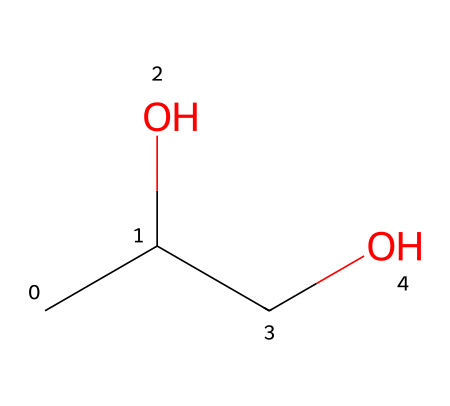What is the name of this chemical? The SMILES representation indicates a linear structure with a specific arrangement of carbon and oxygen atoms. This corresponds to the well-known compound used as a preservative, which is propylene glycol.
Answer: propylene glycol How many carbon atoms are in this molecule? Analyzing the SMILES structure, we identify two carbon atoms represented by the "C" characters. Thus, there are two carbon atoms in total.
Answer: two What functional groups are present in propylene glycol? Reviewing the structure reveals hydroxyl groups (-OH) attached to the carbon atoms. This indicates the presence of alcohol functional groups in the molecular structure.
Answer: alcohol What is the molecular formula of propylene glycol? Based on the molecular structure derived from the SMILES notation, we can deduce that it consists of three carbon atoms, eight hydrogen atoms, and two oxygen atoms, leading to the molecular formula C3H8O2.
Answer: C3H8O2 How many hydroxyl groups does propylene glycol contain? In the structure indicated by the SMILES, we see two hydroxyl groups (-OH), as there are two locations in the chain where oxygen is bonded to hydrogen.
Answer: two What type of compound is propylene glycol classified as? Given the presence of hydroxyl groups and its typical usage as a preservative, propylene glycol is classified as a diol or glycol, specifically an alcohol-type compound.
Answer: diol 